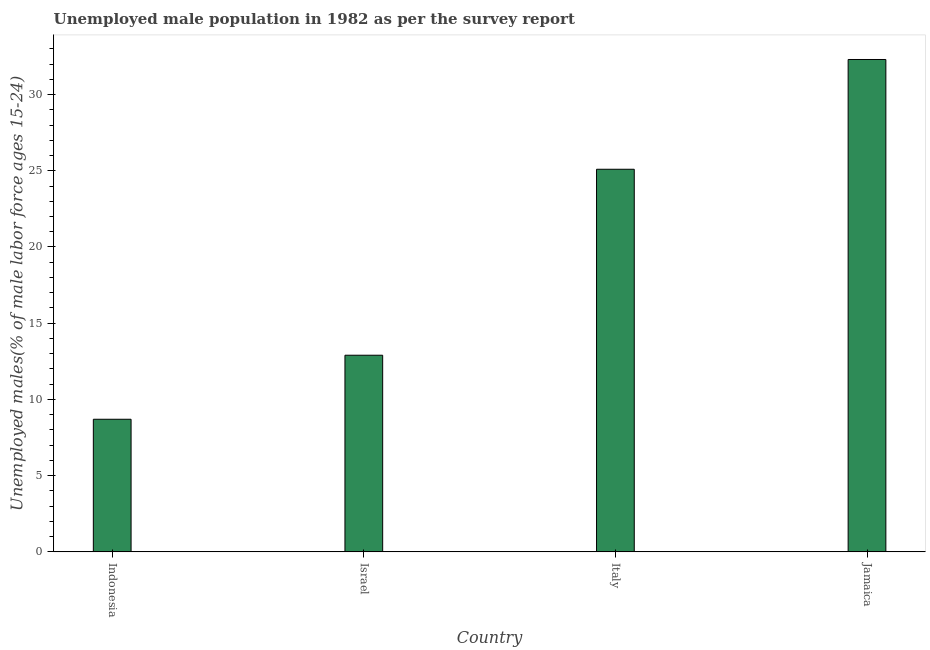Does the graph contain grids?
Provide a short and direct response. No. What is the title of the graph?
Give a very brief answer. Unemployed male population in 1982 as per the survey report. What is the label or title of the X-axis?
Offer a terse response. Country. What is the label or title of the Y-axis?
Ensure brevity in your answer.  Unemployed males(% of male labor force ages 15-24). What is the unemployed male youth in Jamaica?
Provide a short and direct response. 32.3. Across all countries, what is the maximum unemployed male youth?
Your answer should be very brief. 32.3. Across all countries, what is the minimum unemployed male youth?
Your answer should be very brief. 8.7. In which country was the unemployed male youth maximum?
Provide a succinct answer. Jamaica. In which country was the unemployed male youth minimum?
Provide a succinct answer. Indonesia. What is the sum of the unemployed male youth?
Provide a succinct answer. 79. What is the difference between the unemployed male youth in Indonesia and Jamaica?
Make the answer very short. -23.6. What is the average unemployed male youth per country?
Provide a succinct answer. 19.75. What is the median unemployed male youth?
Ensure brevity in your answer.  19. In how many countries, is the unemployed male youth greater than 30 %?
Make the answer very short. 1. What is the ratio of the unemployed male youth in Indonesia to that in Jamaica?
Your response must be concise. 0.27. Is the difference between the unemployed male youth in Indonesia and Israel greater than the difference between any two countries?
Keep it short and to the point. No. Is the sum of the unemployed male youth in Indonesia and Italy greater than the maximum unemployed male youth across all countries?
Offer a terse response. Yes. What is the difference between the highest and the lowest unemployed male youth?
Offer a terse response. 23.6. How many bars are there?
Offer a very short reply. 4. How many countries are there in the graph?
Your answer should be very brief. 4. What is the difference between two consecutive major ticks on the Y-axis?
Keep it short and to the point. 5. What is the Unemployed males(% of male labor force ages 15-24) of Indonesia?
Keep it short and to the point. 8.7. What is the Unemployed males(% of male labor force ages 15-24) in Israel?
Your answer should be compact. 12.9. What is the Unemployed males(% of male labor force ages 15-24) of Italy?
Offer a terse response. 25.1. What is the Unemployed males(% of male labor force ages 15-24) in Jamaica?
Keep it short and to the point. 32.3. What is the difference between the Unemployed males(% of male labor force ages 15-24) in Indonesia and Italy?
Ensure brevity in your answer.  -16.4. What is the difference between the Unemployed males(% of male labor force ages 15-24) in Indonesia and Jamaica?
Provide a short and direct response. -23.6. What is the difference between the Unemployed males(% of male labor force ages 15-24) in Israel and Jamaica?
Ensure brevity in your answer.  -19.4. What is the ratio of the Unemployed males(% of male labor force ages 15-24) in Indonesia to that in Israel?
Make the answer very short. 0.67. What is the ratio of the Unemployed males(% of male labor force ages 15-24) in Indonesia to that in Italy?
Give a very brief answer. 0.35. What is the ratio of the Unemployed males(% of male labor force ages 15-24) in Indonesia to that in Jamaica?
Your answer should be very brief. 0.27. What is the ratio of the Unemployed males(% of male labor force ages 15-24) in Israel to that in Italy?
Provide a short and direct response. 0.51. What is the ratio of the Unemployed males(% of male labor force ages 15-24) in Israel to that in Jamaica?
Your answer should be compact. 0.4. What is the ratio of the Unemployed males(% of male labor force ages 15-24) in Italy to that in Jamaica?
Offer a terse response. 0.78. 